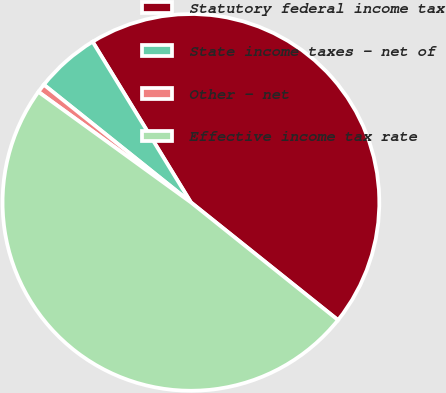Convert chart to OTSL. <chart><loc_0><loc_0><loc_500><loc_500><pie_chart><fcel>Statutory federal income tax<fcel>State income taxes - net of<fcel>Other - net<fcel>Effective income tax rate<nl><fcel>44.48%<fcel>5.52%<fcel>0.76%<fcel>49.24%<nl></chart> 